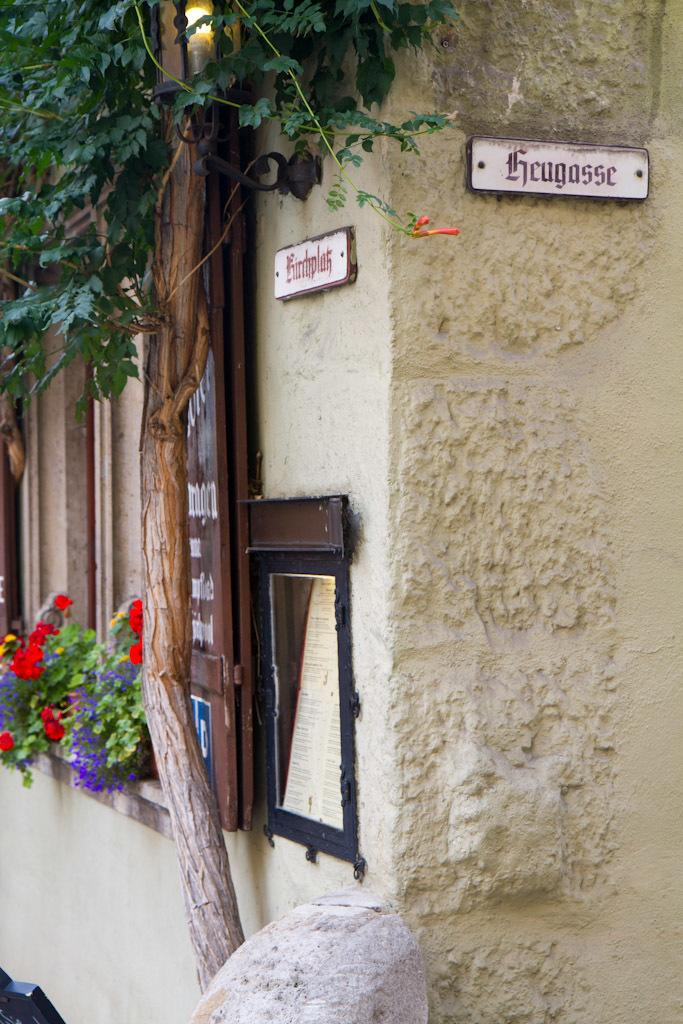What type of vegetation is on the left side of the image? There is a tree and flower plants on the left side of the image. What can be seen on the wall in the image? There is a name plate board on the wall in the image. How many beetles can be seen crawling on the tree in the image? There are no beetles present in the image; it features a tree and flower plants. What type of animal is grazing near the flower plants in the image? There are no animals present in the image; it only features a tree, flower plants, and a name plate board. 